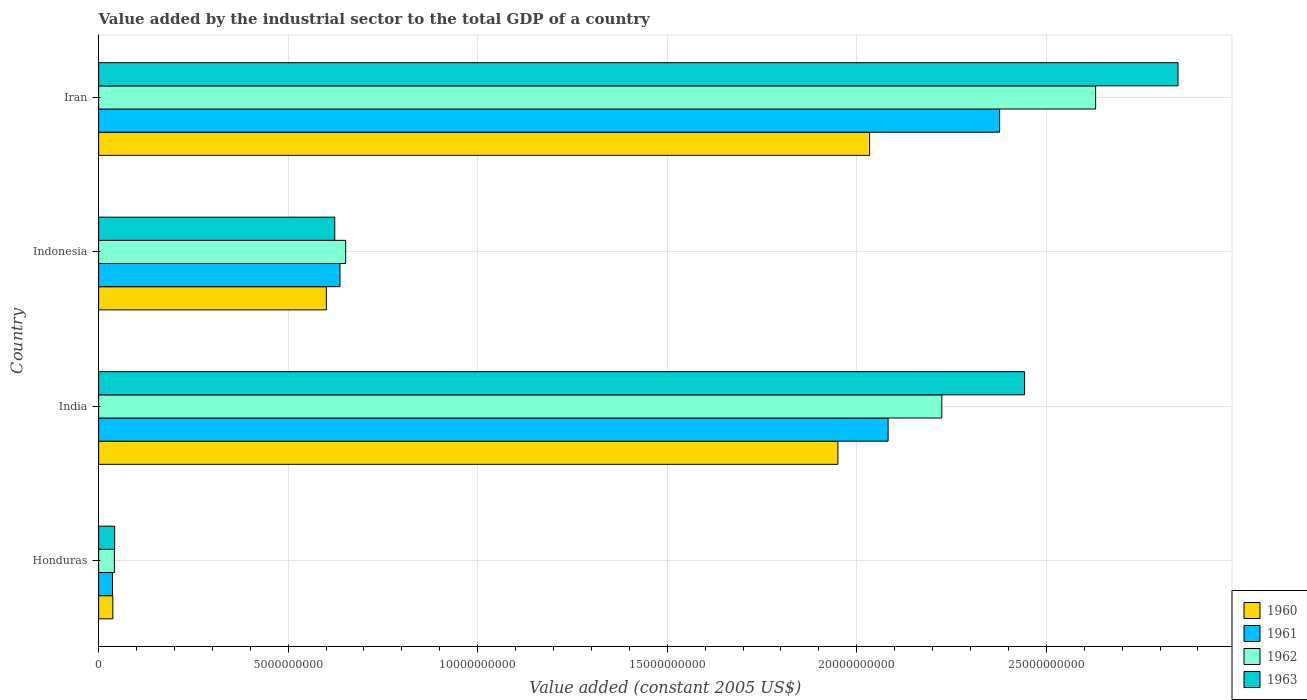How many groups of bars are there?
Make the answer very short. 4. Are the number of bars on each tick of the Y-axis equal?
Ensure brevity in your answer.  Yes. How many bars are there on the 4th tick from the top?
Your response must be concise. 4. What is the label of the 1st group of bars from the top?
Offer a very short reply. Iran. In how many cases, is the number of bars for a given country not equal to the number of legend labels?
Make the answer very short. 0. What is the value added by the industrial sector in 1960 in Indonesia?
Give a very brief answer. 6.01e+09. Across all countries, what is the maximum value added by the industrial sector in 1960?
Keep it short and to the point. 2.03e+1. Across all countries, what is the minimum value added by the industrial sector in 1962?
Ensure brevity in your answer.  4.16e+08. In which country was the value added by the industrial sector in 1962 maximum?
Provide a short and direct response. Iran. In which country was the value added by the industrial sector in 1962 minimum?
Provide a succinct answer. Honduras. What is the total value added by the industrial sector in 1961 in the graph?
Give a very brief answer. 5.13e+1. What is the difference between the value added by the industrial sector in 1962 in India and that in Indonesia?
Provide a short and direct response. 1.57e+1. What is the difference between the value added by the industrial sector in 1962 in India and the value added by the industrial sector in 1963 in Indonesia?
Offer a terse response. 1.60e+1. What is the average value added by the industrial sector in 1961 per country?
Your response must be concise. 1.28e+1. What is the difference between the value added by the industrial sector in 1962 and value added by the industrial sector in 1960 in Honduras?
Ensure brevity in your answer.  4.07e+07. In how many countries, is the value added by the industrial sector in 1963 greater than 25000000000 US$?
Your answer should be very brief. 1. What is the ratio of the value added by the industrial sector in 1960 in Honduras to that in India?
Keep it short and to the point. 0.02. Is the value added by the industrial sector in 1961 in India less than that in Indonesia?
Offer a terse response. No. What is the difference between the highest and the second highest value added by the industrial sector in 1961?
Offer a terse response. 2.94e+09. What is the difference between the highest and the lowest value added by the industrial sector in 1960?
Offer a very short reply. 2.00e+1. In how many countries, is the value added by the industrial sector in 1961 greater than the average value added by the industrial sector in 1961 taken over all countries?
Offer a very short reply. 2. Are all the bars in the graph horizontal?
Your answer should be compact. Yes. Does the graph contain grids?
Keep it short and to the point. Yes. Where does the legend appear in the graph?
Provide a succinct answer. Bottom right. How many legend labels are there?
Offer a terse response. 4. How are the legend labels stacked?
Keep it short and to the point. Vertical. What is the title of the graph?
Keep it short and to the point. Value added by the industrial sector to the total GDP of a country. Does "2007" appear as one of the legend labels in the graph?
Your answer should be compact. No. What is the label or title of the X-axis?
Offer a very short reply. Value added (constant 2005 US$). What is the label or title of the Y-axis?
Your answer should be compact. Country. What is the Value added (constant 2005 US$) in 1960 in Honduras?
Your answer should be very brief. 3.75e+08. What is the Value added (constant 2005 US$) in 1961 in Honduras?
Give a very brief answer. 3.66e+08. What is the Value added (constant 2005 US$) in 1962 in Honduras?
Your answer should be very brief. 4.16e+08. What is the Value added (constant 2005 US$) of 1963 in Honduras?
Offer a very short reply. 4.23e+08. What is the Value added (constant 2005 US$) of 1960 in India?
Make the answer very short. 1.95e+1. What is the Value added (constant 2005 US$) of 1961 in India?
Provide a succinct answer. 2.08e+1. What is the Value added (constant 2005 US$) in 1962 in India?
Your response must be concise. 2.22e+1. What is the Value added (constant 2005 US$) in 1963 in India?
Offer a terse response. 2.44e+1. What is the Value added (constant 2005 US$) of 1960 in Indonesia?
Keep it short and to the point. 6.01e+09. What is the Value added (constant 2005 US$) in 1961 in Indonesia?
Give a very brief answer. 6.37e+09. What is the Value added (constant 2005 US$) in 1962 in Indonesia?
Keep it short and to the point. 6.52e+09. What is the Value added (constant 2005 US$) in 1963 in Indonesia?
Give a very brief answer. 6.23e+09. What is the Value added (constant 2005 US$) of 1960 in Iran?
Your answer should be very brief. 2.03e+1. What is the Value added (constant 2005 US$) of 1961 in Iran?
Offer a very short reply. 2.38e+1. What is the Value added (constant 2005 US$) in 1962 in Iran?
Your answer should be compact. 2.63e+1. What is the Value added (constant 2005 US$) in 1963 in Iran?
Ensure brevity in your answer.  2.85e+1. Across all countries, what is the maximum Value added (constant 2005 US$) in 1960?
Offer a very short reply. 2.03e+1. Across all countries, what is the maximum Value added (constant 2005 US$) of 1961?
Provide a short and direct response. 2.38e+1. Across all countries, what is the maximum Value added (constant 2005 US$) of 1962?
Your answer should be compact. 2.63e+1. Across all countries, what is the maximum Value added (constant 2005 US$) of 1963?
Offer a very short reply. 2.85e+1. Across all countries, what is the minimum Value added (constant 2005 US$) in 1960?
Provide a succinct answer. 3.75e+08. Across all countries, what is the minimum Value added (constant 2005 US$) in 1961?
Keep it short and to the point. 3.66e+08. Across all countries, what is the minimum Value added (constant 2005 US$) of 1962?
Your answer should be very brief. 4.16e+08. Across all countries, what is the minimum Value added (constant 2005 US$) in 1963?
Give a very brief answer. 4.23e+08. What is the total Value added (constant 2005 US$) of 1960 in the graph?
Make the answer very short. 4.62e+1. What is the total Value added (constant 2005 US$) in 1961 in the graph?
Offer a very short reply. 5.13e+1. What is the total Value added (constant 2005 US$) in 1962 in the graph?
Provide a succinct answer. 5.55e+1. What is the total Value added (constant 2005 US$) in 1963 in the graph?
Keep it short and to the point. 5.96e+1. What is the difference between the Value added (constant 2005 US$) of 1960 in Honduras and that in India?
Your response must be concise. -1.91e+1. What is the difference between the Value added (constant 2005 US$) of 1961 in Honduras and that in India?
Provide a succinct answer. -2.05e+1. What is the difference between the Value added (constant 2005 US$) in 1962 in Honduras and that in India?
Ensure brevity in your answer.  -2.18e+1. What is the difference between the Value added (constant 2005 US$) in 1963 in Honduras and that in India?
Your response must be concise. -2.40e+1. What is the difference between the Value added (constant 2005 US$) in 1960 in Honduras and that in Indonesia?
Offer a terse response. -5.63e+09. What is the difference between the Value added (constant 2005 US$) in 1961 in Honduras and that in Indonesia?
Provide a succinct answer. -6.00e+09. What is the difference between the Value added (constant 2005 US$) of 1962 in Honduras and that in Indonesia?
Your answer should be very brief. -6.10e+09. What is the difference between the Value added (constant 2005 US$) of 1963 in Honduras and that in Indonesia?
Offer a very short reply. -5.81e+09. What is the difference between the Value added (constant 2005 US$) in 1960 in Honduras and that in Iran?
Your answer should be very brief. -2.00e+1. What is the difference between the Value added (constant 2005 US$) of 1961 in Honduras and that in Iran?
Your answer should be compact. -2.34e+1. What is the difference between the Value added (constant 2005 US$) of 1962 in Honduras and that in Iran?
Give a very brief answer. -2.59e+1. What is the difference between the Value added (constant 2005 US$) in 1963 in Honduras and that in Iran?
Your response must be concise. -2.81e+1. What is the difference between the Value added (constant 2005 US$) in 1960 in India and that in Indonesia?
Give a very brief answer. 1.35e+1. What is the difference between the Value added (constant 2005 US$) in 1961 in India and that in Indonesia?
Your answer should be very brief. 1.45e+1. What is the difference between the Value added (constant 2005 US$) of 1962 in India and that in Indonesia?
Provide a short and direct response. 1.57e+1. What is the difference between the Value added (constant 2005 US$) of 1963 in India and that in Indonesia?
Your response must be concise. 1.82e+1. What is the difference between the Value added (constant 2005 US$) of 1960 in India and that in Iran?
Keep it short and to the point. -8.36e+08. What is the difference between the Value added (constant 2005 US$) of 1961 in India and that in Iran?
Your answer should be very brief. -2.94e+09. What is the difference between the Value added (constant 2005 US$) of 1962 in India and that in Iran?
Keep it short and to the point. -4.06e+09. What is the difference between the Value added (constant 2005 US$) of 1963 in India and that in Iran?
Provide a short and direct response. -4.05e+09. What is the difference between the Value added (constant 2005 US$) in 1960 in Indonesia and that in Iran?
Keep it short and to the point. -1.43e+1. What is the difference between the Value added (constant 2005 US$) of 1961 in Indonesia and that in Iran?
Ensure brevity in your answer.  -1.74e+1. What is the difference between the Value added (constant 2005 US$) of 1962 in Indonesia and that in Iran?
Offer a terse response. -1.98e+1. What is the difference between the Value added (constant 2005 US$) in 1963 in Indonesia and that in Iran?
Provide a succinct answer. -2.22e+1. What is the difference between the Value added (constant 2005 US$) in 1960 in Honduras and the Value added (constant 2005 US$) in 1961 in India?
Give a very brief answer. -2.05e+1. What is the difference between the Value added (constant 2005 US$) of 1960 in Honduras and the Value added (constant 2005 US$) of 1962 in India?
Your answer should be very brief. -2.19e+1. What is the difference between the Value added (constant 2005 US$) of 1960 in Honduras and the Value added (constant 2005 US$) of 1963 in India?
Offer a very short reply. -2.41e+1. What is the difference between the Value added (constant 2005 US$) of 1961 in Honduras and the Value added (constant 2005 US$) of 1962 in India?
Offer a terse response. -2.19e+1. What is the difference between the Value added (constant 2005 US$) in 1961 in Honduras and the Value added (constant 2005 US$) in 1963 in India?
Offer a very short reply. -2.41e+1. What is the difference between the Value added (constant 2005 US$) in 1962 in Honduras and the Value added (constant 2005 US$) in 1963 in India?
Keep it short and to the point. -2.40e+1. What is the difference between the Value added (constant 2005 US$) in 1960 in Honduras and the Value added (constant 2005 US$) in 1961 in Indonesia?
Offer a terse response. -5.99e+09. What is the difference between the Value added (constant 2005 US$) of 1960 in Honduras and the Value added (constant 2005 US$) of 1962 in Indonesia?
Provide a succinct answer. -6.14e+09. What is the difference between the Value added (constant 2005 US$) of 1960 in Honduras and the Value added (constant 2005 US$) of 1963 in Indonesia?
Give a very brief answer. -5.85e+09. What is the difference between the Value added (constant 2005 US$) of 1961 in Honduras and the Value added (constant 2005 US$) of 1962 in Indonesia?
Ensure brevity in your answer.  -6.15e+09. What is the difference between the Value added (constant 2005 US$) of 1961 in Honduras and the Value added (constant 2005 US$) of 1963 in Indonesia?
Offer a terse response. -5.86e+09. What is the difference between the Value added (constant 2005 US$) in 1962 in Honduras and the Value added (constant 2005 US$) in 1963 in Indonesia?
Keep it short and to the point. -5.81e+09. What is the difference between the Value added (constant 2005 US$) of 1960 in Honduras and the Value added (constant 2005 US$) of 1961 in Iran?
Offer a terse response. -2.34e+1. What is the difference between the Value added (constant 2005 US$) of 1960 in Honduras and the Value added (constant 2005 US$) of 1962 in Iran?
Your response must be concise. -2.59e+1. What is the difference between the Value added (constant 2005 US$) in 1960 in Honduras and the Value added (constant 2005 US$) in 1963 in Iran?
Keep it short and to the point. -2.81e+1. What is the difference between the Value added (constant 2005 US$) in 1961 in Honduras and the Value added (constant 2005 US$) in 1962 in Iran?
Offer a very short reply. -2.59e+1. What is the difference between the Value added (constant 2005 US$) in 1961 in Honduras and the Value added (constant 2005 US$) in 1963 in Iran?
Your answer should be very brief. -2.81e+1. What is the difference between the Value added (constant 2005 US$) of 1962 in Honduras and the Value added (constant 2005 US$) of 1963 in Iran?
Give a very brief answer. -2.81e+1. What is the difference between the Value added (constant 2005 US$) in 1960 in India and the Value added (constant 2005 US$) in 1961 in Indonesia?
Give a very brief answer. 1.31e+1. What is the difference between the Value added (constant 2005 US$) of 1960 in India and the Value added (constant 2005 US$) of 1962 in Indonesia?
Keep it short and to the point. 1.30e+1. What is the difference between the Value added (constant 2005 US$) of 1960 in India and the Value added (constant 2005 US$) of 1963 in Indonesia?
Offer a terse response. 1.33e+1. What is the difference between the Value added (constant 2005 US$) in 1961 in India and the Value added (constant 2005 US$) in 1962 in Indonesia?
Make the answer very short. 1.43e+1. What is the difference between the Value added (constant 2005 US$) of 1961 in India and the Value added (constant 2005 US$) of 1963 in Indonesia?
Provide a succinct answer. 1.46e+1. What is the difference between the Value added (constant 2005 US$) in 1962 in India and the Value added (constant 2005 US$) in 1963 in Indonesia?
Offer a very short reply. 1.60e+1. What is the difference between the Value added (constant 2005 US$) in 1960 in India and the Value added (constant 2005 US$) in 1961 in Iran?
Ensure brevity in your answer.  -4.27e+09. What is the difference between the Value added (constant 2005 US$) in 1960 in India and the Value added (constant 2005 US$) in 1962 in Iran?
Ensure brevity in your answer.  -6.80e+09. What is the difference between the Value added (constant 2005 US$) of 1960 in India and the Value added (constant 2005 US$) of 1963 in Iran?
Your answer should be very brief. -8.97e+09. What is the difference between the Value added (constant 2005 US$) in 1961 in India and the Value added (constant 2005 US$) in 1962 in Iran?
Your answer should be compact. -5.48e+09. What is the difference between the Value added (constant 2005 US$) in 1961 in India and the Value added (constant 2005 US$) in 1963 in Iran?
Ensure brevity in your answer.  -7.65e+09. What is the difference between the Value added (constant 2005 US$) in 1962 in India and the Value added (constant 2005 US$) in 1963 in Iran?
Offer a very short reply. -6.23e+09. What is the difference between the Value added (constant 2005 US$) in 1960 in Indonesia and the Value added (constant 2005 US$) in 1961 in Iran?
Make the answer very short. -1.78e+1. What is the difference between the Value added (constant 2005 US$) in 1960 in Indonesia and the Value added (constant 2005 US$) in 1962 in Iran?
Provide a short and direct response. -2.03e+1. What is the difference between the Value added (constant 2005 US$) of 1960 in Indonesia and the Value added (constant 2005 US$) of 1963 in Iran?
Ensure brevity in your answer.  -2.25e+1. What is the difference between the Value added (constant 2005 US$) of 1961 in Indonesia and the Value added (constant 2005 US$) of 1962 in Iran?
Ensure brevity in your answer.  -1.99e+1. What is the difference between the Value added (constant 2005 US$) in 1961 in Indonesia and the Value added (constant 2005 US$) in 1963 in Iran?
Your response must be concise. -2.21e+1. What is the difference between the Value added (constant 2005 US$) of 1962 in Indonesia and the Value added (constant 2005 US$) of 1963 in Iran?
Offer a very short reply. -2.20e+1. What is the average Value added (constant 2005 US$) of 1960 per country?
Offer a very short reply. 1.16e+1. What is the average Value added (constant 2005 US$) in 1961 per country?
Provide a short and direct response. 1.28e+1. What is the average Value added (constant 2005 US$) of 1962 per country?
Provide a succinct answer. 1.39e+1. What is the average Value added (constant 2005 US$) in 1963 per country?
Provide a short and direct response. 1.49e+1. What is the difference between the Value added (constant 2005 US$) in 1960 and Value added (constant 2005 US$) in 1961 in Honduras?
Your answer should be compact. 9.37e+06. What is the difference between the Value added (constant 2005 US$) in 1960 and Value added (constant 2005 US$) in 1962 in Honduras?
Ensure brevity in your answer.  -4.07e+07. What is the difference between the Value added (constant 2005 US$) in 1960 and Value added (constant 2005 US$) in 1963 in Honduras?
Your answer should be very brief. -4.79e+07. What is the difference between the Value added (constant 2005 US$) of 1961 and Value added (constant 2005 US$) of 1962 in Honduras?
Ensure brevity in your answer.  -5.00e+07. What is the difference between the Value added (constant 2005 US$) in 1961 and Value added (constant 2005 US$) in 1963 in Honduras?
Your response must be concise. -5.72e+07. What is the difference between the Value added (constant 2005 US$) of 1962 and Value added (constant 2005 US$) of 1963 in Honduras?
Ensure brevity in your answer.  -7.19e+06. What is the difference between the Value added (constant 2005 US$) in 1960 and Value added (constant 2005 US$) in 1961 in India?
Provide a short and direct response. -1.32e+09. What is the difference between the Value added (constant 2005 US$) in 1960 and Value added (constant 2005 US$) in 1962 in India?
Your answer should be very brief. -2.74e+09. What is the difference between the Value added (constant 2005 US$) of 1960 and Value added (constant 2005 US$) of 1963 in India?
Give a very brief answer. -4.92e+09. What is the difference between the Value added (constant 2005 US$) of 1961 and Value added (constant 2005 US$) of 1962 in India?
Offer a terse response. -1.42e+09. What is the difference between the Value added (constant 2005 US$) of 1961 and Value added (constant 2005 US$) of 1963 in India?
Provide a succinct answer. -3.60e+09. What is the difference between the Value added (constant 2005 US$) of 1962 and Value added (constant 2005 US$) of 1963 in India?
Your answer should be compact. -2.18e+09. What is the difference between the Value added (constant 2005 US$) in 1960 and Value added (constant 2005 US$) in 1961 in Indonesia?
Your answer should be very brief. -3.60e+08. What is the difference between the Value added (constant 2005 US$) in 1960 and Value added (constant 2005 US$) in 1962 in Indonesia?
Offer a terse response. -5.10e+08. What is the difference between the Value added (constant 2005 US$) of 1960 and Value added (constant 2005 US$) of 1963 in Indonesia?
Your answer should be compact. -2.22e+08. What is the difference between the Value added (constant 2005 US$) of 1961 and Value added (constant 2005 US$) of 1962 in Indonesia?
Keep it short and to the point. -1.50e+08. What is the difference between the Value added (constant 2005 US$) in 1961 and Value added (constant 2005 US$) in 1963 in Indonesia?
Give a very brief answer. 1.38e+08. What is the difference between the Value added (constant 2005 US$) in 1962 and Value added (constant 2005 US$) in 1963 in Indonesia?
Offer a very short reply. 2.88e+08. What is the difference between the Value added (constant 2005 US$) of 1960 and Value added (constant 2005 US$) of 1961 in Iran?
Offer a very short reply. -3.43e+09. What is the difference between the Value added (constant 2005 US$) in 1960 and Value added (constant 2005 US$) in 1962 in Iran?
Ensure brevity in your answer.  -5.96e+09. What is the difference between the Value added (constant 2005 US$) of 1960 and Value added (constant 2005 US$) of 1963 in Iran?
Your answer should be compact. -8.14e+09. What is the difference between the Value added (constant 2005 US$) of 1961 and Value added (constant 2005 US$) of 1962 in Iran?
Provide a succinct answer. -2.53e+09. What is the difference between the Value added (constant 2005 US$) in 1961 and Value added (constant 2005 US$) in 1963 in Iran?
Offer a terse response. -4.71e+09. What is the difference between the Value added (constant 2005 US$) in 1962 and Value added (constant 2005 US$) in 1963 in Iran?
Your answer should be compact. -2.17e+09. What is the ratio of the Value added (constant 2005 US$) of 1960 in Honduras to that in India?
Offer a terse response. 0.02. What is the ratio of the Value added (constant 2005 US$) in 1961 in Honduras to that in India?
Your answer should be compact. 0.02. What is the ratio of the Value added (constant 2005 US$) in 1962 in Honduras to that in India?
Offer a terse response. 0.02. What is the ratio of the Value added (constant 2005 US$) in 1963 in Honduras to that in India?
Offer a very short reply. 0.02. What is the ratio of the Value added (constant 2005 US$) of 1960 in Honduras to that in Indonesia?
Offer a terse response. 0.06. What is the ratio of the Value added (constant 2005 US$) of 1961 in Honduras to that in Indonesia?
Keep it short and to the point. 0.06. What is the ratio of the Value added (constant 2005 US$) in 1962 in Honduras to that in Indonesia?
Your response must be concise. 0.06. What is the ratio of the Value added (constant 2005 US$) in 1963 in Honduras to that in Indonesia?
Provide a short and direct response. 0.07. What is the ratio of the Value added (constant 2005 US$) in 1960 in Honduras to that in Iran?
Provide a succinct answer. 0.02. What is the ratio of the Value added (constant 2005 US$) of 1961 in Honduras to that in Iran?
Offer a very short reply. 0.02. What is the ratio of the Value added (constant 2005 US$) of 1962 in Honduras to that in Iran?
Your answer should be very brief. 0.02. What is the ratio of the Value added (constant 2005 US$) of 1963 in Honduras to that in Iran?
Your answer should be compact. 0.01. What is the ratio of the Value added (constant 2005 US$) of 1960 in India to that in Indonesia?
Provide a short and direct response. 3.25. What is the ratio of the Value added (constant 2005 US$) of 1961 in India to that in Indonesia?
Your answer should be compact. 3.27. What is the ratio of the Value added (constant 2005 US$) of 1962 in India to that in Indonesia?
Your answer should be compact. 3.41. What is the ratio of the Value added (constant 2005 US$) in 1963 in India to that in Indonesia?
Your answer should be compact. 3.92. What is the ratio of the Value added (constant 2005 US$) in 1960 in India to that in Iran?
Give a very brief answer. 0.96. What is the ratio of the Value added (constant 2005 US$) of 1961 in India to that in Iran?
Give a very brief answer. 0.88. What is the ratio of the Value added (constant 2005 US$) in 1962 in India to that in Iran?
Ensure brevity in your answer.  0.85. What is the ratio of the Value added (constant 2005 US$) in 1963 in India to that in Iran?
Your answer should be compact. 0.86. What is the ratio of the Value added (constant 2005 US$) in 1960 in Indonesia to that in Iran?
Keep it short and to the point. 0.3. What is the ratio of the Value added (constant 2005 US$) of 1961 in Indonesia to that in Iran?
Provide a short and direct response. 0.27. What is the ratio of the Value added (constant 2005 US$) in 1962 in Indonesia to that in Iran?
Give a very brief answer. 0.25. What is the ratio of the Value added (constant 2005 US$) of 1963 in Indonesia to that in Iran?
Provide a short and direct response. 0.22. What is the difference between the highest and the second highest Value added (constant 2005 US$) of 1960?
Provide a succinct answer. 8.36e+08. What is the difference between the highest and the second highest Value added (constant 2005 US$) of 1961?
Ensure brevity in your answer.  2.94e+09. What is the difference between the highest and the second highest Value added (constant 2005 US$) of 1962?
Your answer should be compact. 4.06e+09. What is the difference between the highest and the second highest Value added (constant 2005 US$) in 1963?
Offer a terse response. 4.05e+09. What is the difference between the highest and the lowest Value added (constant 2005 US$) of 1960?
Make the answer very short. 2.00e+1. What is the difference between the highest and the lowest Value added (constant 2005 US$) in 1961?
Offer a terse response. 2.34e+1. What is the difference between the highest and the lowest Value added (constant 2005 US$) in 1962?
Your answer should be compact. 2.59e+1. What is the difference between the highest and the lowest Value added (constant 2005 US$) of 1963?
Your answer should be very brief. 2.81e+1. 